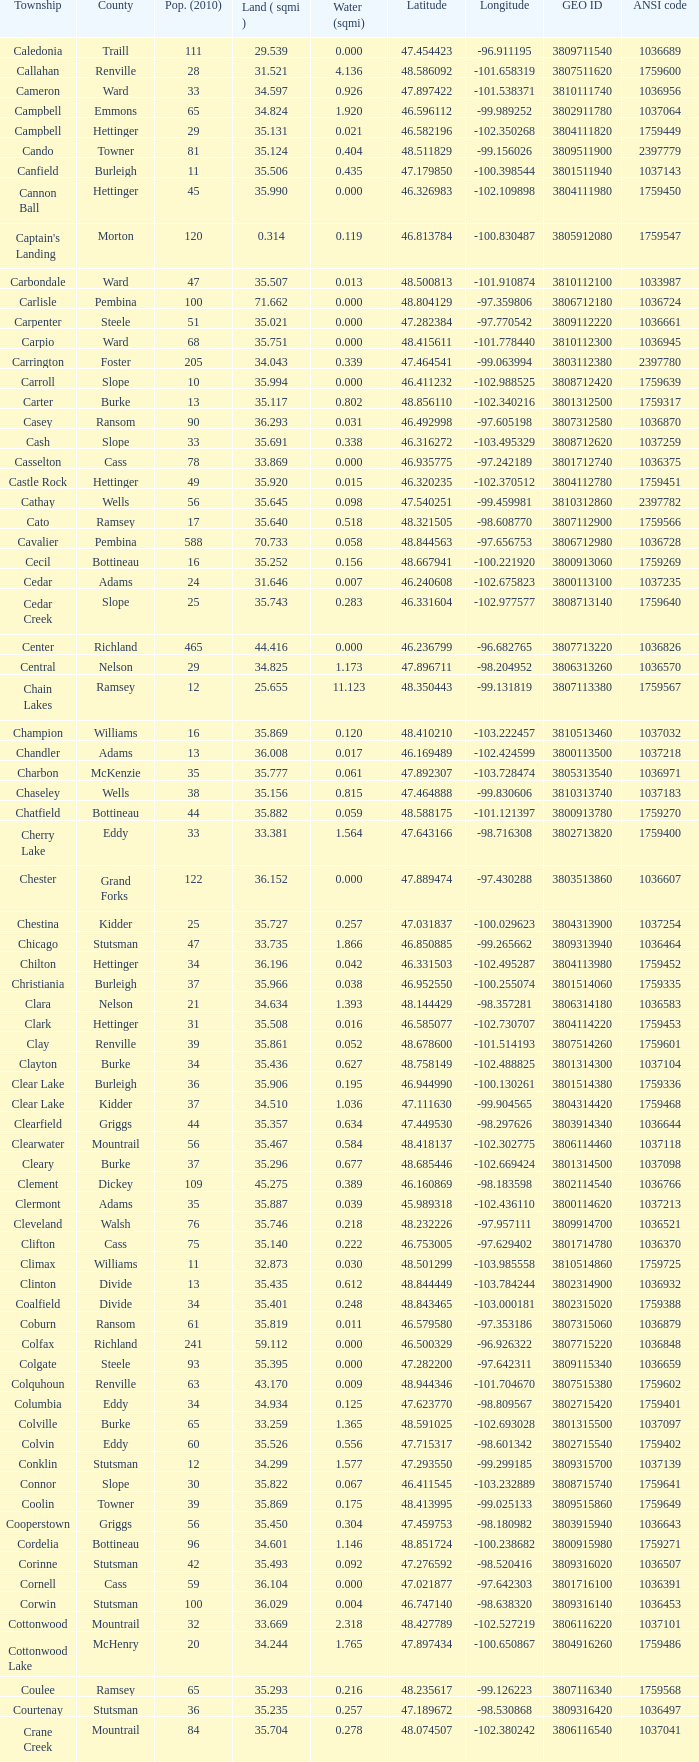What was the latitude of the Clearwater townsship? 48.418137. 